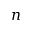<formula> <loc_0><loc_0><loc_500><loc_500>n</formula> 